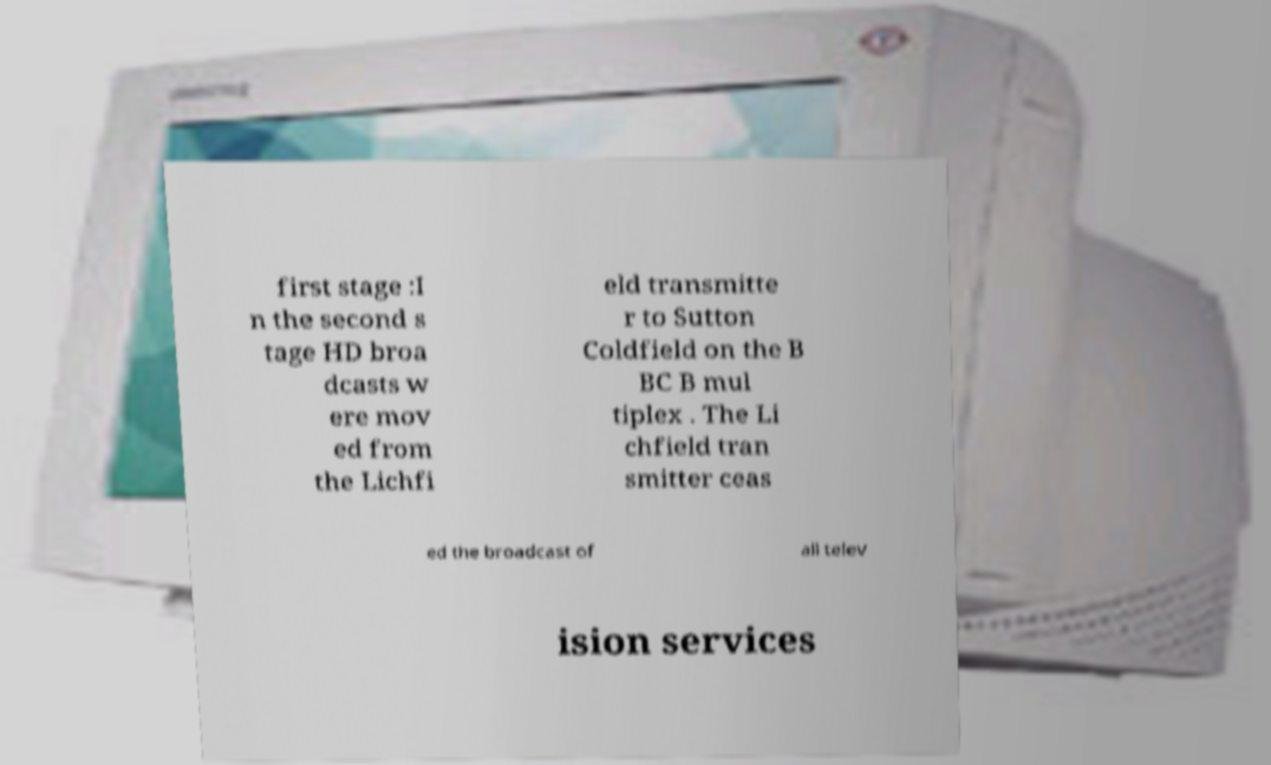Could you extract and type out the text from this image? first stage :I n the second s tage HD broa dcasts w ere mov ed from the Lichfi eld transmitte r to Sutton Coldfield on the B BC B mul tiplex . The Li chfield tran smitter ceas ed the broadcast of all telev ision services 